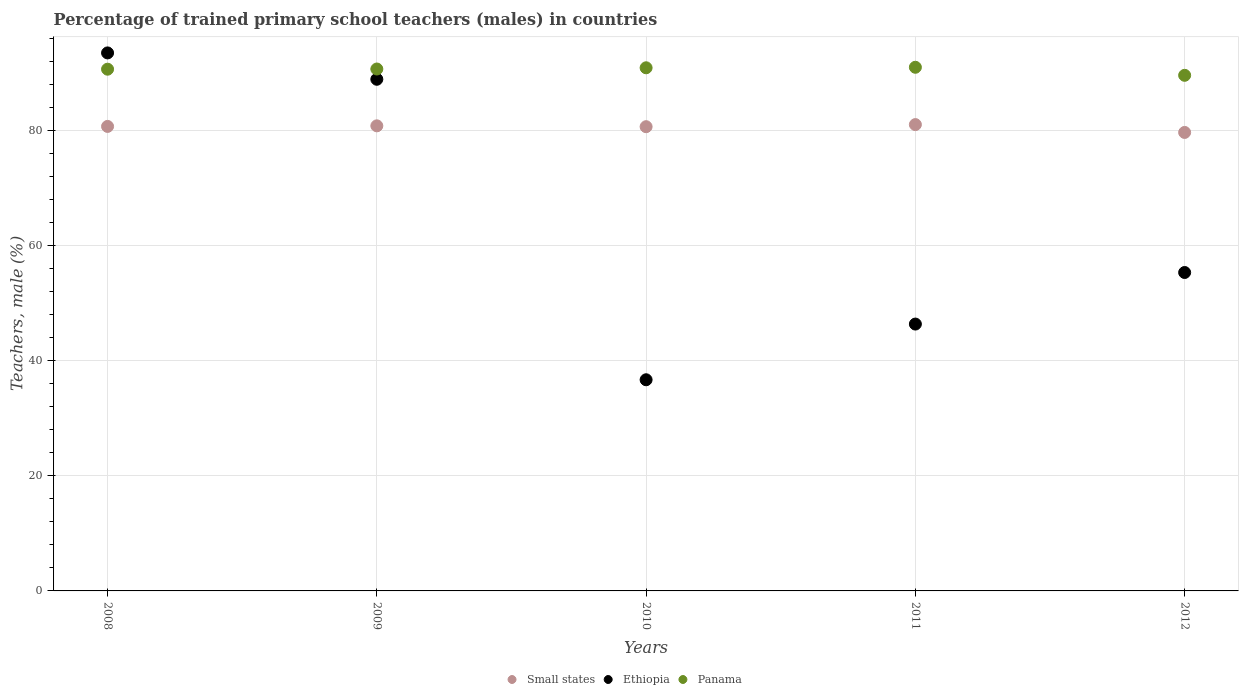What is the percentage of trained primary school teachers (males) in Panama in 2009?
Make the answer very short. 90.71. Across all years, what is the maximum percentage of trained primary school teachers (males) in Panama?
Provide a short and direct response. 91.01. Across all years, what is the minimum percentage of trained primary school teachers (males) in Small states?
Offer a terse response. 79.69. In which year was the percentage of trained primary school teachers (males) in Small states minimum?
Your response must be concise. 2012. What is the total percentage of trained primary school teachers (males) in Ethiopia in the graph?
Provide a succinct answer. 320.87. What is the difference between the percentage of trained primary school teachers (males) in Panama in 2008 and that in 2010?
Keep it short and to the point. -0.24. What is the difference between the percentage of trained primary school teachers (males) in Small states in 2012 and the percentage of trained primary school teachers (males) in Panama in 2008?
Offer a very short reply. -10.99. What is the average percentage of trained primary school teachers (males) in Ethiopia per year?
Your response must be concise. 64.17. In the year 2009, what is the difference between the percentage of trained primary school teachers (males) in Panama and percentage of trained primary school teachers (males) in Small states?
Give a very brief answer. 9.88. In how many years, is the percentage of trained primary school teachers (males) in Small states greater than 76 %?
Provide a succinct answer. 5. What is the ratio of the percentage of trained primary school teachers (males) in Panama in 2008 to that in 2010?
Keep it short and to the point. 1. What is the difference between the highest and the second highest percentage of trained primary school teachers (males) in Small states?
Your response must be concise. 0.21. What is the difference between the highest and the lowest percentage of trained primary school teachers (males) in Panama?
Keep it short and to the point. 1.4. Is the percentage of trained primary school teachers (males) in Ethiopia strictly greater than the percentage of trained primary school teachers (males) in Panama over the years?
Your answer should be compact. No. Is the percentage of trained primary school teachers (males) in Panama strictly less than the percentage of trained primary school teachers (males) in Ethiopia over the years?
Provide a short and direct response. No. Does the graph contain any zero values?
Make the answer very short. No. What is the title of the graph?
Your answer should be very brief. Percentage of trained primary school teachers (males) in countries. Does "Tunisia" appear as one of the legend labels in the graph?
Provide a succinct answer. No. What is the label or title of the X-axis?
Provide a succinct answer. Years. What is the label or title of the Y-axis?
Offer a very short reply. Teachers, male (%). What is the Teachers, male (%) in Small states in 2008?
Provide a succinct answer. 80.73. What is the Teachers, male (%) in Ethiopia in 2008?
Keep it short and to the point. 93.51. What is the Teachers, male (%) of Panama in 2008?
Make the answer very short. 90.68. What is the Teachers, male (%) in Small states in 2009?
Your response must be concise. 80.84. What is the Teachers, male (%) in Ethiopia in 2009?
Keep it short and to the point. 88.93. What is the Teachers, male (%) in Panama in 2009?
Make the answer very short. 90.71. What is the Teachers, male (%) in Small states in 2010?
Your answer should be compact. 80.69. What is the Teachers, male (%) in Ethiopia in 2010?
Ensure brevity in your answer.  36.7. What is the Teachers, male (%) of Panama in 2010?
Offer a terse response. 90.92. What is the Teachers, male (%) of Small states in 2011?
Your response must be concise. 81.05. What is the Teachers, male (%) of Ethiopia in 2011?
Your answer should be very brief. 46.38. What is the Teachers, male (%) of Panama in 2011?
Keep it short and to the point. 91.01. What is the Teachers, male (%) of Small states in 2012?
Make the answer very short. 79.69. What is the Teachers, male (%) of Ethiopia in 2012?
Provide a succinct answer. 55.34. What is the Teachers, male (%) in Panama in 2012?
Give a very brief answer. 89.62. Across all years, what is the maximum Teachers, male (%) of Small states?
Keep it short and to the point. 81.05. Across all years, what is the maximum Teachers, male (%) of Ethiopia?
Keep it short and to the point. 93.51. Across all years, what is the maximum Teachers, male (%) in Panama?
Provide a succinct answer. 91.01. Across all years, what is the minimum Teachers, male (%) in Small states?
Offer a very short reply. 79.69. Across all years, what is the minimum Teachers, male (%) of Ethiopia?
Keep it short and to the point. 36.7. Across all years, what is the minimum Teachers, male (%) of Panama?
Offer a very short reply. 89.62. What is the total Teachers, male (%) in Small states in the graph?
Keep it short and to the point. 403. What is the total Teachers, male (%) in Ethiopia in the graph?
Your response must be concise. 320.87. What is the total Teachers, male (%) of Panama in the graph?
Your answer should be compact. 452.95. What is the difference between the Teachers, male (%) in Small states in 2008 and that in 2009?
Provide a short and direct response. -0.1. What is the difference between the Teachers, male (%) in Ethiopia in 2008 and that in 2009?
Provide a succinct answer. 4.58. What is the difference between the Teachers, male (%) in Panama in 2008 and that in 2009?
Keep it short and to the point. -0.03. What is the difference between the Teachers, male (%) of Small states in 2008 and that in 2010?
Provide a short and direct response. 0.05. What is the difference between the Teachers, male (%) in Ethiopia in 2008 and that in 2010?
Make the answer very short. 56.81. What is the difference between the Teachers, male (%) of Panama in 2008 and that in 2010?
Keep it short and to the point. -0.24. What is the difference between the Teachers, male (%) of Small states in 2008 and that in 2011?
Make the answer very short. -0.32. What is the difference between the Teachers, male (%) of Ethiopia in 2008 and that in 2011?
Your response must be concise. 47.13. What is the difference between the Teachers, male (%) of Panama in 2008 and that in 2011?
Offer a very short reply. -0.33. What is the difference between the Teachers, male (%) of Small states in 2008 and that in 2012?
Your response must be concise. 1.05. What is the difference between the Teachers, male (%) in Ethiopia in 2008 and that in 2012?
Make the answer very short. 38.17. What is the difference between the Teachers, male (%) in Panama in 2008 and that in 2012?
Provide a short and direct response. 1.06. What is the difference between the Teachers, male (%) in Small states in 2009 and that in 2010?
Make the answer very short. 0.15. What is the difference between the Teachers, male (%) in Ethiopia in 2009 and that in 2010?
Your response must be concise. 52.23. What is the difference between the Teachers, male (%) of Panama in 2009 and that in 2010?
Your answer should be very brief. -0.21. What is the difference between the Teachers, male (%) in Small states in 2009 and that in 2011?
Provide a short and direct response. -0.21. What is the difference between the Teachers, male (%) of Ethiopia in 2009 and that in 2011?
Your answer should be compact. 42.55. What is the difference between the Teachers, male (%) of Panama in 2009 and that in 2011?
Ensure brevity in your answer.  -0.3. What is the difference between the Teachers, male (%) of Small states in 2009 and that in 2012?
Offer a very short reply. 1.15. What is the difference between the Teachers, male (%) of Ethiopia in 2009 and that in 2012?
Ensure brevity in your answer.  33.59. What is the difference between the Teachers, male (%) of Panama in 2009 and that in 2012?
Keep it short and to the point. 1.1. What is the difference between the Teachers, male (%) in Small states in 2010 and that in 2011?
Provide a succinct answer. -0.36. What is the difference between the Teachers, male (%) in Ethiopia in 2010 and that in 2011?
Offer a terse response. -9.68. What is the difference between the Teachers, male (%) in Panama in 2010 and that in 2011?
Give a very brief answer. -0.09. What is the difference between the Teachers, male (%) of Small states in 2010 and that in 2012?
Your answer should be compact. 1. What is the difference between the Teachers, male (%) in Ethiopia in 2010 and that in 2012?
Your answer should be compact. -18.64. What is the difference between the Teachers, male (%) of Panama in 2010 and that in 2012?
Keep it short and to the point. 1.31. What is the difference between the Teachers, male (%) in Small states in 2011 and that in 2012?
Your answer should be very brief. 1.36. What is the difference between the Teachers, male (%) in Ethiopia in 2011 and that in 2012?
Make the answer very short. -8.96. What is the difference between the Teachers, male (%) of Panama in 2011 and that in 2012?
Give a very brief answer. 1.4. What is the difference between the Teachers, male (%) of Small states in 2008 and the Teachers, male (%) of Ethiopia in 2009?
Offer a very short reply. -8.19. What is the difference between the Teachers, male (%) in Small states in 2008 and the Teachers, male (%) in Panama in 2009?
Your response must be concise. -9.98. What is the difference between the Teachers, male (%) of Ethiopia in 2008 and the Teachers, male (%) of Panama in 2009?
Your answer should be compact. 2.8. What is the difference between the Teachers, male (%) in Small states in 2008 and the Teachers, male (%) in Ethiopia in 2010?
Give a very brief answer. 44.03. What is the difference between the Teachers, male (%) of Small states in 2008 and the Teachers, male (%) of Panama in 2010?
Make the answer very short. -10.19. What is the difference between the Teachers, male (%) in Ethiopia in 2008 and the Teachers, male (%) in Panama in 2010?
Your answer should be very brief. 2.59. What is the difference between the Teachers, male (%) of Small states in 2008 and the Teachers, male (%) of Ethiopia in 2011?
Keep it short and to the point. 34.35. What is the difference between the Teachers, male (%) of Small states in 2008 and the Teachers, male (%) of Panama in 2011?
Your answer should be very brief. -10.28. What is the difference between the Teachers, male (%) in Ethiopia in 2008 and the Teachers, male (%) in Panama in 2011?
Your response must be concise. 2.5. What is the difference between the Teachers, male (%) of Small states in 2008 and the Teachers, male (%) of Ethiopia in 2012?
Make the answer very short. 25.39. What is the difference between the Teachers, male (%) of Small states in 2008 and the Teachers, male (%) of Panama in 2012?
Ensure brevity in your answer.  -8.88. What is the difference between the Teachers, male (%) of Ethiopia in 2008 and the Teachers, male (%) of Panama in 2012?
Keep it short and to the point. 3.89. What is the difference between the Teachers, male (%) in Small states in 2009 and the Teachers, male (%) in Ethiopia in 2010?
Your answer should be compact. 44.14. What is the difference between the Teachers, male (%) of Small states in 2009 and the Teachers, male (%) of Panama in 2010?
Ensure brevity in your answer.  -10.09. What is the difference between the Teachers, male (%) in Ethiopia in 2009 and the Teachers, male (%) in Panama in 2010?
Keep it short and to the point. -2. What is the difference between the Teachers, male (%) of Small states in 2009 and the Teachers, male (%) of Ethiopia in 2011?
Provide a short and direct response. 34.45. What is the difference between the Teachers, male (%) of Small states in 2009 and the Teachers, male (%) of Panama in 2011?
Your answer should be very brief. -10.18. What is the difference between the Teachers, male (%) of Ethiopia in 2009 and the Teachers, male (%) of Panama in 2011?
Your answer should be compact. -2.08. What is the difference between the Teachers, male (%) of Small states in 2009 and the Teachers, male (%) of Ethiopia in 2012?
Your answer should be very brief. 25.49. What is the difference between the Teachers, male (%) in Small states in 2009 and the Teachers, male (%) in Panama in 2012?
Ensure brevity in your answer.  -8.78. What is the difference between the Teachers, male (%) in Ethiopia in 2009 and the Teachers, male (%) in Panama in 2012?
Your answer should be compact. -0.69. What is the difference between the Teachers, male (%) in Small states in 2010 and the Teachers, male (%) in Ethiopia in 2011?
Provide a short and direct response. 34.3. What is the difference between the Teachers, male (%) of Small states in 2010 and the Teachers, male (%) of Panama in 2011?
Your answer should be very brief. -10.33. What is the difference between the Teachers, male (%) in Ethiopia in 2010 and the Teachers, male (%) in Panama in 2011?
Ensure brevity in your answer.  -54.31. What is the difference between the Teachers, male (%) of Small states in 2010 and the Teachers, male (%) of Ethiopia in 2012?
Make the answer very short. 25.34. What is the difference between the Teachers, male (%) of Small states in 2010 and the Teachers, male (%) of Panama in 2012?
Offer a very short reply. -8.93. What is the difference between the Teachers, male (%) in Ethiopia in 2010 and the Teachers, male (%) in Panama in 2012?
Provide a succinct answer. -52.92. What is the difference between the Teachers, male (%) of Small states in 2011 and the Teachers, male (%) of Ethiopia in 2012?
Ensure brevity in your answer.  25.71. What is the difference between the Teachers, male (%) of Small states in 2011 and the Teachers, male (%) of Panama in 2012?
Your response must be concise. -8.57. What is the difference between the Teachers, male (%) in Ethiopia in 2011 and the Teachers, male (%) in Panama in 2012?
Provide a short and direct response. -43.24. What is the average Teachers, male (%) in Small states per year?
Offer a terse response. 80.6. What is the average Teachers, male (%) in Ethiopia per year?
Your answer should be compact. 64.17. What is the average Teachers, male (%) in Panama per year?
Your answer should be very brief. 90.59. In the year 2008, what is the difference between the Teachers, male (%) of Small states and Teachers, male (%) of Ethiopia?
Offer a very short reply. -12.78. In the year 2008, what is the difference between the Teachers, male (%) of Small states and Teachers, male (%) of Panama?
Provide a succinct answer. -9.95. In the year 2008, what is the difference between the Teachers, male (%) of Ethiopia and Teachers, male (%) of Panama?
Your response must be concise. 2.83. In the year 2009, what is the difference between the Teachers, male (%) of Small states and Teachers, male (%) of Ethiopia?
Offer a terse response. -8.09. In the year 2009, what is the difference between the Teachers, male (%) in Small states and Teachers, male (%) in Panama?
Your answer should be very brief. -9.88. In the year 2009, what is the difference between the Teachers, male (%) of Ethiopia and Teachers, male (%) of Panama?
Ensure brevity in your answer.  -1.78. In the year 2010, what is the difference between the Teachers, male (%) in Small states and Teachers, male (%) in Ethiopia?
Your answer should be compact. 43.99. In the year 2010, what is the difference between the Teachers, male (%) of Small states and Teachers, male (%) of Panama?
Provide a short and direct response. -10.24. In the year 2010, what is the difference between the Teachers, male (%) of Ethiopia and Teachers, male (%) of Panama?
Offer a terse response. -54.22. In the year 2011, what is the difference between the Teachers, male (%) of Small states and Teachers, male (%) of Ethiopia?
Offer a terse response. 34.67. In the year 2011, what is the difference between the Teachers, male (%) of Small states and Teachers, male (%) of Panama?
Make the answer very short. -9.96. In the year 2011, what is the difference between the Teachers, male (%) of Ethiopia and Teachers, male (%) of Panama?
Your response must be concise. -44.63. In the year 2012, what is the difference between the Teachers, male (%) of Small states and Teachers, male (%) of Ethiopia?
Provide a short and direct response. 24.34. In the year 2012, what is the difference between the Teachers, male (%) of Small states and Teachers, male (%) of Panama?
Provide a short and direct response. -9.93. In the year 2012, what is the difference between the Teachers, male (%) in Ethiopia and Teachers, male (%) in Panama?
Make the answer very short. -34.27. What is the ratio of the Teachers, male (%) of Small states in 2008 to that in 2009?
Give a very brief answer. 1. What is the ratio of the Teachers, male (%) in Ethiopia in 2008 to that in 2009?
Provide a succinct answer. 1.05. What is the ratio of the Teachers, male (%) in Panama in 2008 to that in 2009?
Keep it short and to the point. 1. What is the ratio of the Teachers, male (%) in Small states in 2008 to that in 2010?
Your answer should be very brief. 1. What is the ratio of the Teachers, male (%) in Ethiopia in 2008 to that in 2010?
Provide a short and direct response. 2.55. What is the ratio of the Teachers, male (%) in Ethiopia in 2008 to that in 2011?
Your answer should be very brief. 2.02. What is the ratio of the Teachers, male (%) in Small states in 2008 to that in 2012?
Keep it short and to the point. 1.01. What is the ratio of the Teachers, male (%) in Ethiopia in 2008 to that in 2012?
Keep it short and to the point. 1.69. What is the ratio of the Teachers, male (%) of Panama in 2008 to that in 2012?
Provide a short and direct response. 1.01. What is the ratio of the Teachers, male (%) in Ethiopia in 2009 to that in 2010?
Ensure brevity in your answer.  2.42. What is the ratio of the Teachers, male (%) in Panama in 2009 to that in 2010?
Your answer should be very brief. 1. What is the ratio of the Teachers, male (%) of Ethiopia in 2009 to that in 2011?
Offer a terse response. 1.92. What is the ratio of the Teachers, male (%) in Panama in 2009 to that in 2011?
Provide a succinct answer. 1. What is the ratio of the Teachers, male (%) in Small states in 2009 to that in 2012?
Offer a very short reply. 1.01. What is the ratio of the Teachers, male (%) in Ethiopia in 2009 to that in 2012?
Offer a very short reply. 1.61. What is the ratio of the Teachers, male (%) of Panama in 2009 to that in 2012?
Ensure brevity in your answer.  1.01. What is the ratio of the Teachers, male (%) in Ethiopia in 2010 to that in 2011?
Keep it short and to the point. 0.79. What is the ratio of the Teachers, male (%) in Small states in 2010 to that in 2012?
Offer a very short reply. 1.01. What is the ratio of the Teachers, male (%) of Ethiopia in 2010 to that in 2012?
Offer a terse response. 0.66. What is the ratio of the Teachers, male (%) in Panama in 2010 to that in 2012?
Your response must be concise. 1.01. What is the ratio of the Teachers, male (%) in Small states in 2011 to that in 2012?
Your answer should be compact. 1.02. What is the ratio of the Teachers, male (%) in Ethiopia in 2011 to that in 2012?
Provide a succinct answer. 0.84. What is the ratio of the Teachers, male (%) of Panama in 2011 to that in 2012?
Give a very brief answer. 1.02. What is the difference between the highest and the second highest Teachers, male (%) of Small states?
Keep it short and to the point. 0.21. What is the difference between the highest and the second highest Teachers, male (%) in Ethiopia?
Make the answer very short. 4.58. What is the difference between the highest and the second highest Teachers, male (%) in Panama?
Give a very brief answer. 0.09. What is the difference between the highest and the lowest Teachers, male (%) in Small states?
Give a very brief answer. 1.36. What is the difference between the highest and the lowest Teachers, male (%) of Ethiopia?
Make the answer very short. 56.81. What is the difference between the highest and the lowest Teachers, male (%) of Panama?
Offer a very short reply. 1.4. 